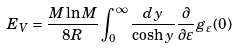Convert formula to latex. <formula><loc_0><loc_0><loc_500><loc_500>E _ { V } = \frac { M \ln M } { 8 R } \int _ { 0 } ^ { \infty } \frac { d y } { \cosh y } \frac { \partial } { \partial \varepsilon } g _ { \varepsilon } ( 0 )</formula> 